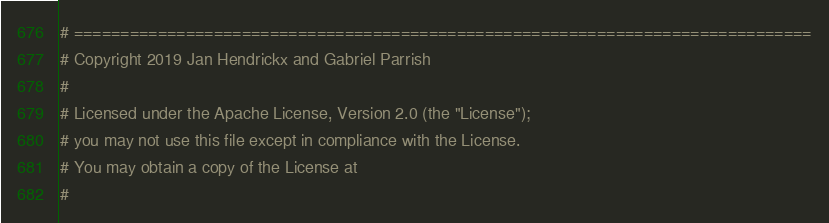Convert code to text. <code><loc_0><loc_0><loc_500><loc_500><_Python_># ===============================================================================
# Copyright 2019 Jan Hendrickx and Gabriel Parrish
#
# Licensed under the Apache License, Version 2.0 (the "License");
# you may not use this file except in compliance with the License.
# You may obtain a copy of the License at
#</code> 